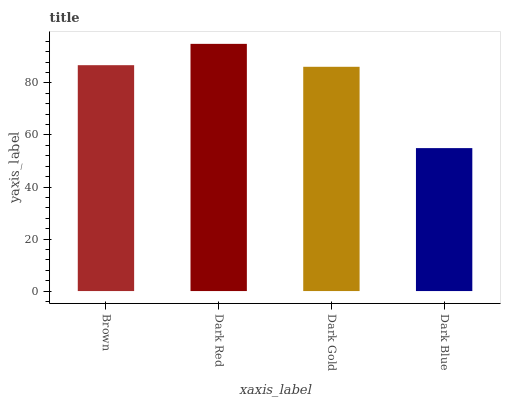Is Dark Blue the minimum?
Answer yes or no. Yes. Is Dark Red the maximum?
Answer yes or no. Yes. Is Dark Gold the minimum?
Answer yes or no. No. Is Dark Gold the maximum?
Answer yes or no. No. Is Dark Red greater than Dark Gold?
Answer yes or no. Yes. Is Dark Gold less than Dark Red?
Answer yes or no. Yes. Is Dark Gold greater than Dark Red?
Answer yes or no. No. Is Dark Red less than Dark Gold?
Answer yes or no. No. Is Brown the high median?
Answer yes or no. Yes. Is Dark Gold the low median?
Answer yes or no. Yes. Is Dark Red the high median?
Answer yes or no. No. Is Dark Blue the low median?
Answer yes or no. No. 